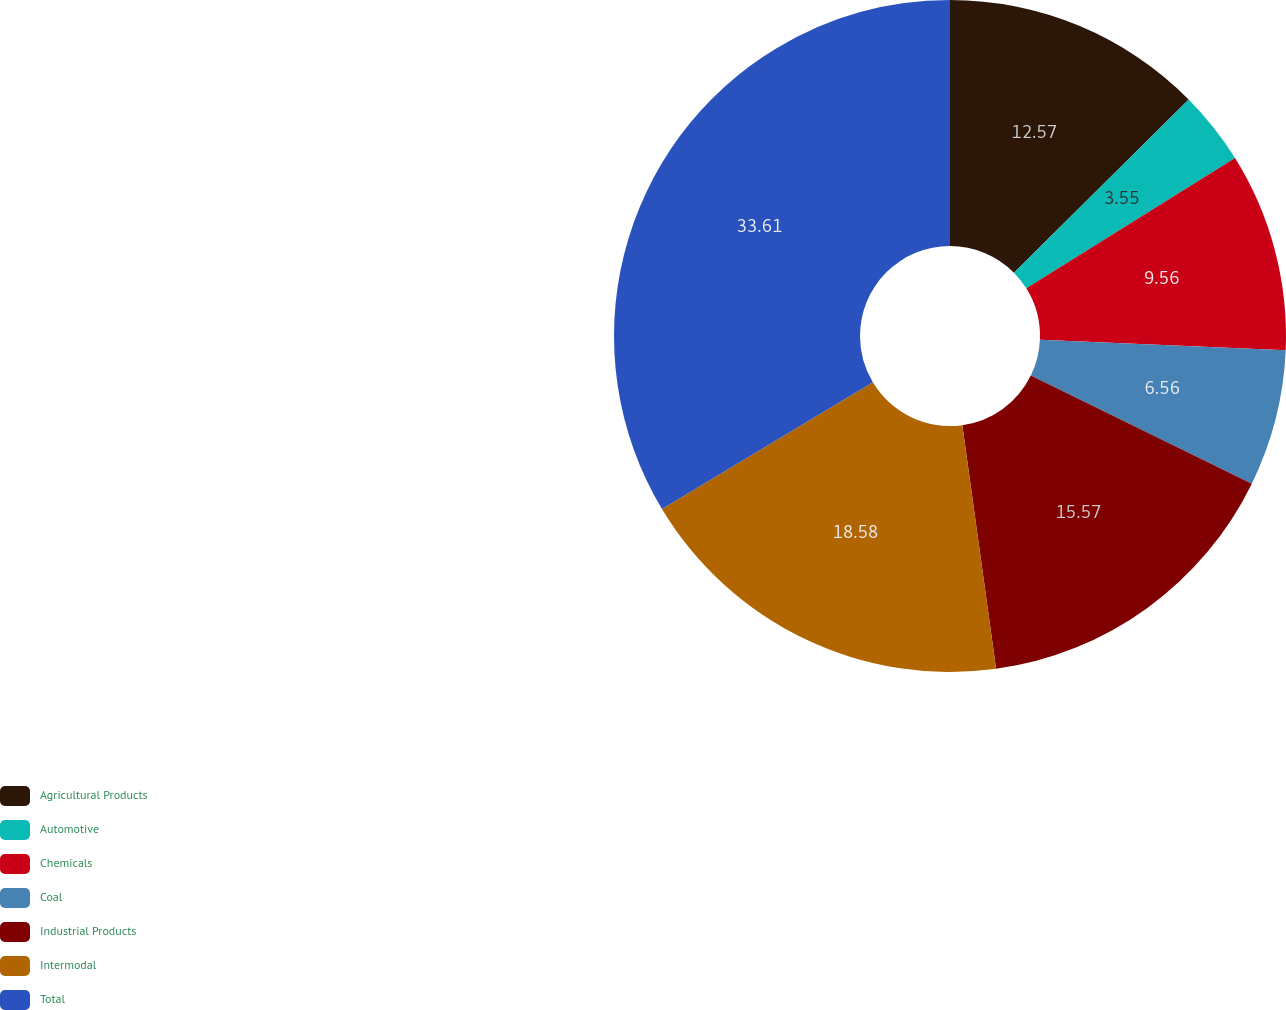Convert chart to OTSL. <chart><loc_0><loc_0><loc_500><loc_500><pie_chart><fcel>Agricultural Products<fcel>Automotive<fcel>Chemicals<fcel>Coal<fcel>Industrial Products<fcel>Intermodal<fcel>Total<nl><fcel>12.57%<fcel>3.55%<fcel>9.56%<fcel>6.56%<fcel>15.57%<fcel>18.58%<fcel>33.61%<nl></chart> 